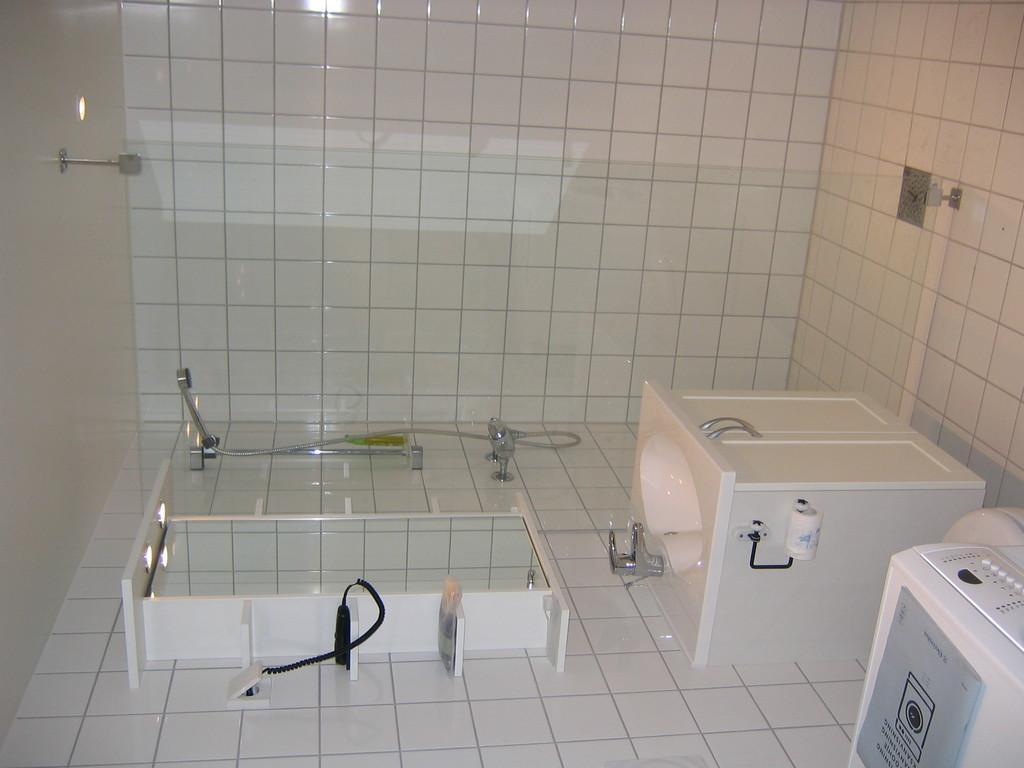Please provide a concise description of this image. In this picture I can see there is a wash basin, a mirror with shelves and there are few items placed on the shelf, there is a glass in the center. There are taps and I can see there are tiles on the wall. 